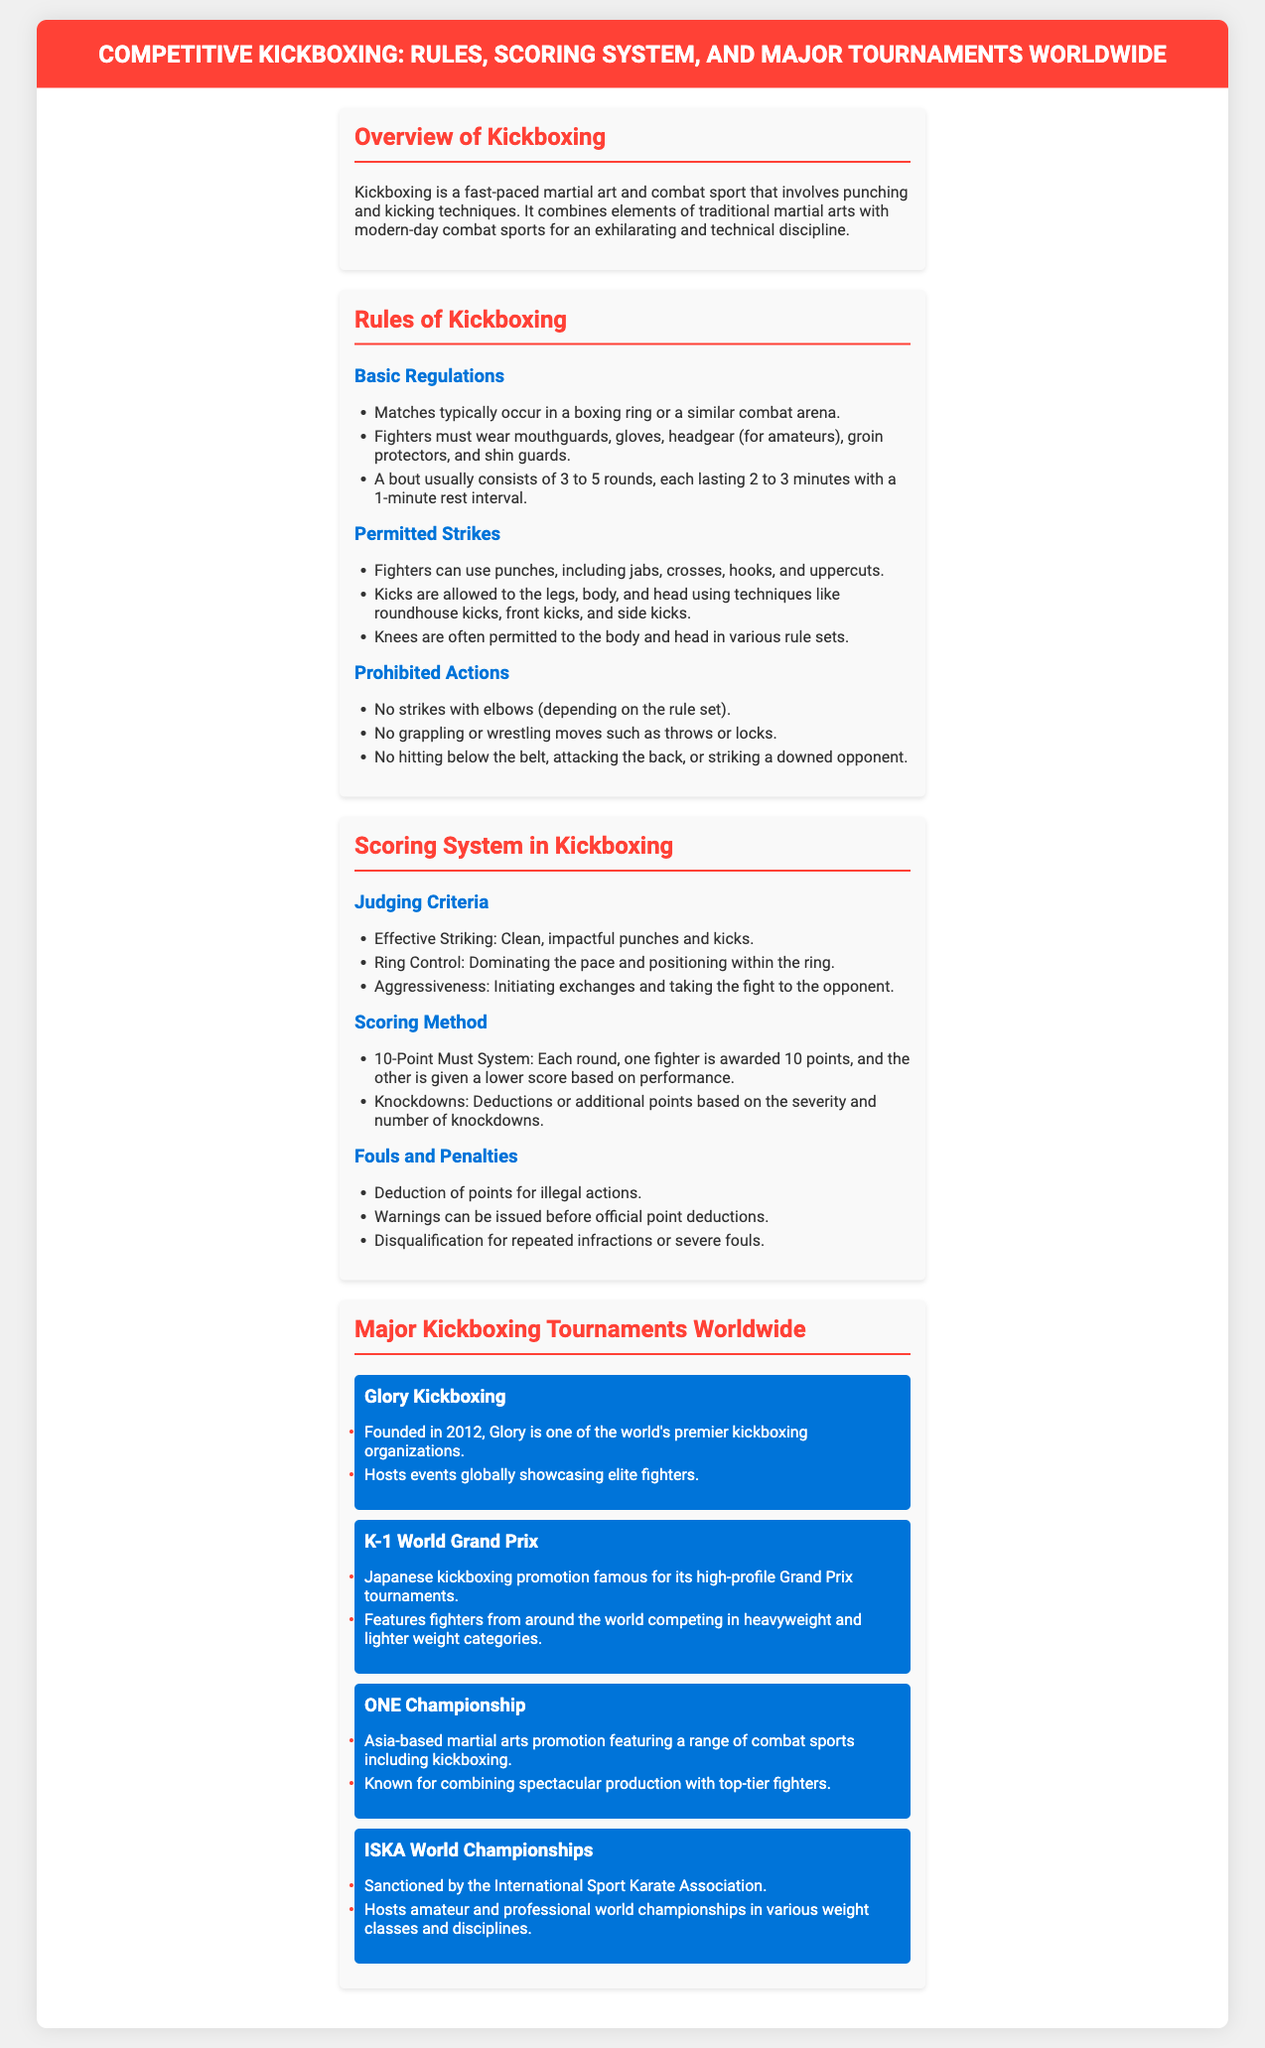What is kickboxing? Kickboxing is defined as a fast-paced martial art and combat sport that involves punching and kicking techniques.
Answer: fast-paced martial art and combat sport How many rounds does a typical kickboxing bout consist of? A bout usually consists of 3 to 5 rounds, which is specified in the document.
Answer: 3 to 5 rounds What equipment must fighters wear? The document lists the necessary protective equipment that fighters must wear during matches.
Answer: mouthguards, gloves, headgear, groin protectors, shin guards What is the scoring system used in kickboxing? The document mentions the 10-Point Must System as the scoring method in kickboxing matches.
Answer: 10-Point Must System Which organization was founded in 2012? The document provides information about various major kickboxing organizations, including which one was founded in 2012.
Answer: Glory Kickboxing What is the significance of knockdowns in scoring? The scoring method includes specific mentions of how knockdowns affect the points awarded, indicating their importance.
Answer: Deductions or additional points based on severity and number of knockdowns What are the judging criteria in kickboxing? The document outlines key criteria used for judging in kickboxing which includes multiple aspects.
Answer: Effective Striking, Ring Control, Aggressiveness Which championship is sanctioned by the International Sport Karate Association? The document specifies which championship is overseen by this organization.
Answer: ISKA World Championships 